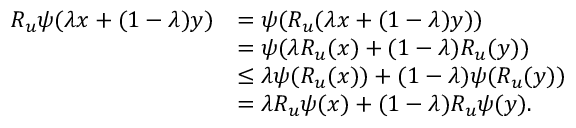<formula> <loc_0><loc_0><loc_500><loc_500>\begin{array} { r l } { R _ { u } \psi ( \lambda x + ( 1 - \lambda ) y ) } & { = \psi ( R _ { u } ( \lambda x + ( 1 - \lambda ) y ) ) } \\ & { = \psi ( \lambda R _ { u } ( x ) + ( 1 - \lambda ) R _ { u } ( y ) ) } \\ & { \leq \lambda \psi ( R _ { u } ( x ) ) + ( 1 - \lambda ) \psi ( R _ { u } ( y ) ) } \\ & { = \lambda R _ { u } \psi ( x ) + ( 1 - \lambda ) R _ { u } \psi ( y ) . } \end{array}</formula> 